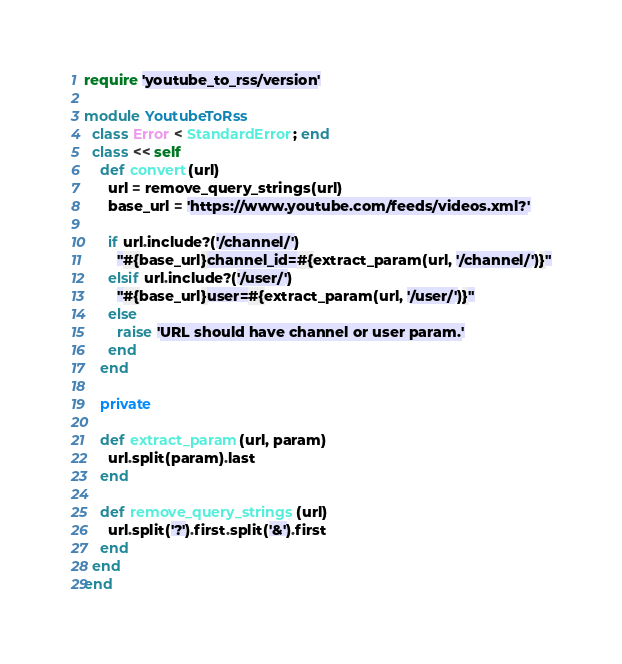<code> <loc_0><loc_0><loc_500><loc_500><_Ruby_>require 'youtube_to_rss/version'

module YoutubeToRss
  class Error < StandardError; end
  class << self
    def convert(url)
      url = remove_query_strings(url)
      base_url = 'https://www.youtube.com/feeds/videos.xml?'

      if url.include?('/channel/')
        "#{base_url}channel_id=#{extract_param(url, '/channel/')}"
      elsif url.include?('/user/')
        "#{base_url}user=#{extract_param(url, '/user/')}"
      else
        raise 'URL should have channel or user param.'
      end
    end

    private

    def extract_param(url, param)
      url.split(param).last
    end

    def remove_query_strings(url)
      url.split('?').first.split('&').first
    end
  end
end
</code> 